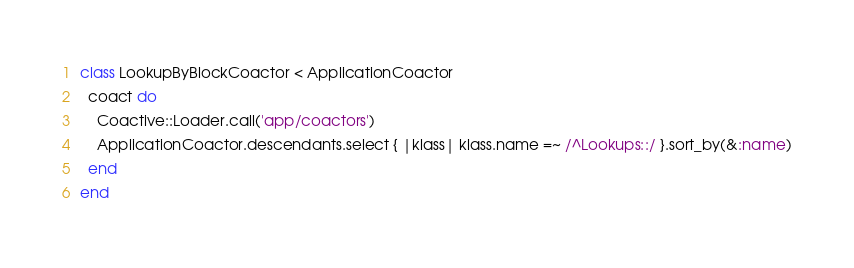<code> <loc_0><loc_0><loc_500><loc_500><_Ruby_>class LookupByBlockCoactor < ApplicationCoactor
  coact do
    Coactive::Loader.call('app/coactors')
    ApplicationCoactor.descendants.select { |klass| klass.name =~ /^Lookups::/ }.sort_by(&:name)
  end
end
</code> 